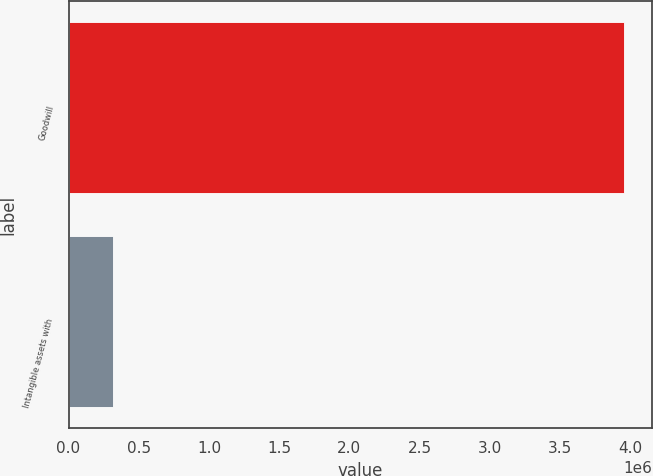Convert chart to OTSL. <chart><loc_0><loc_0><loc_500><loc_500><bar_chart><fcel>Goodwill<fcel>Intangible assets with<nl><fcel>3.9559e+06<fcel>313449<nl></chart> 